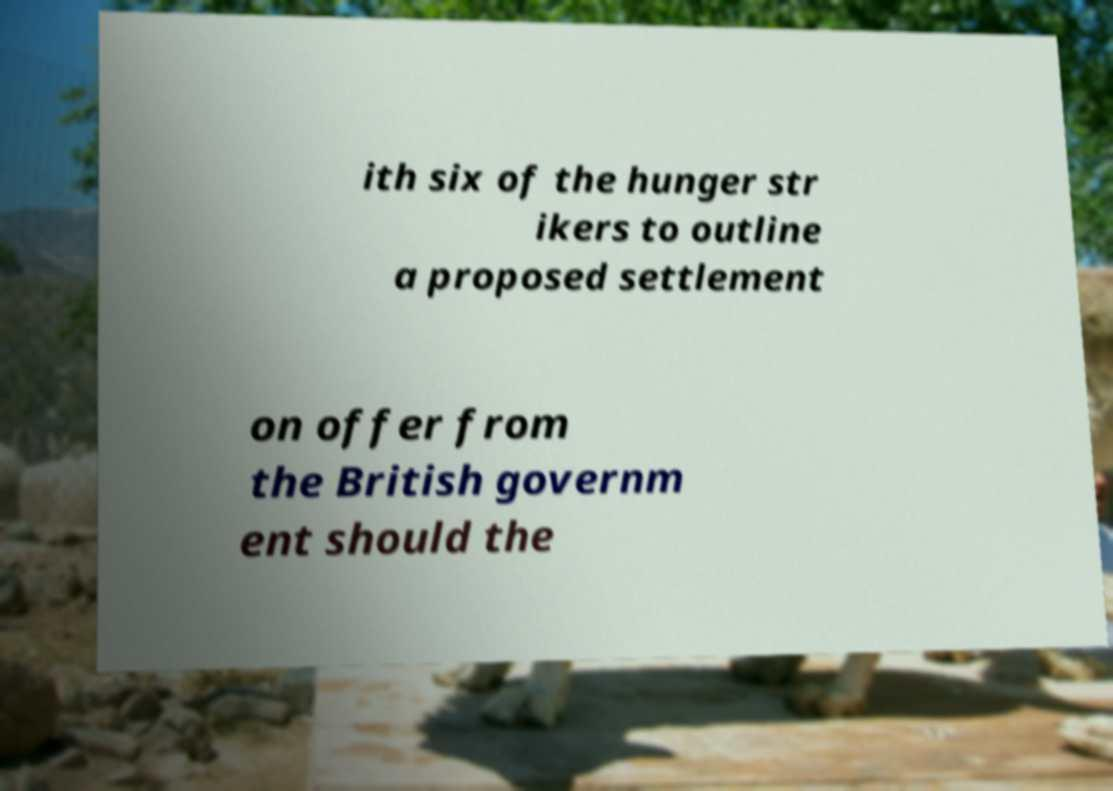Could you extract and type out the text from this image? ith six of the hunger str ikers to outline a proposed settlement on offer from the British governm ent should the 